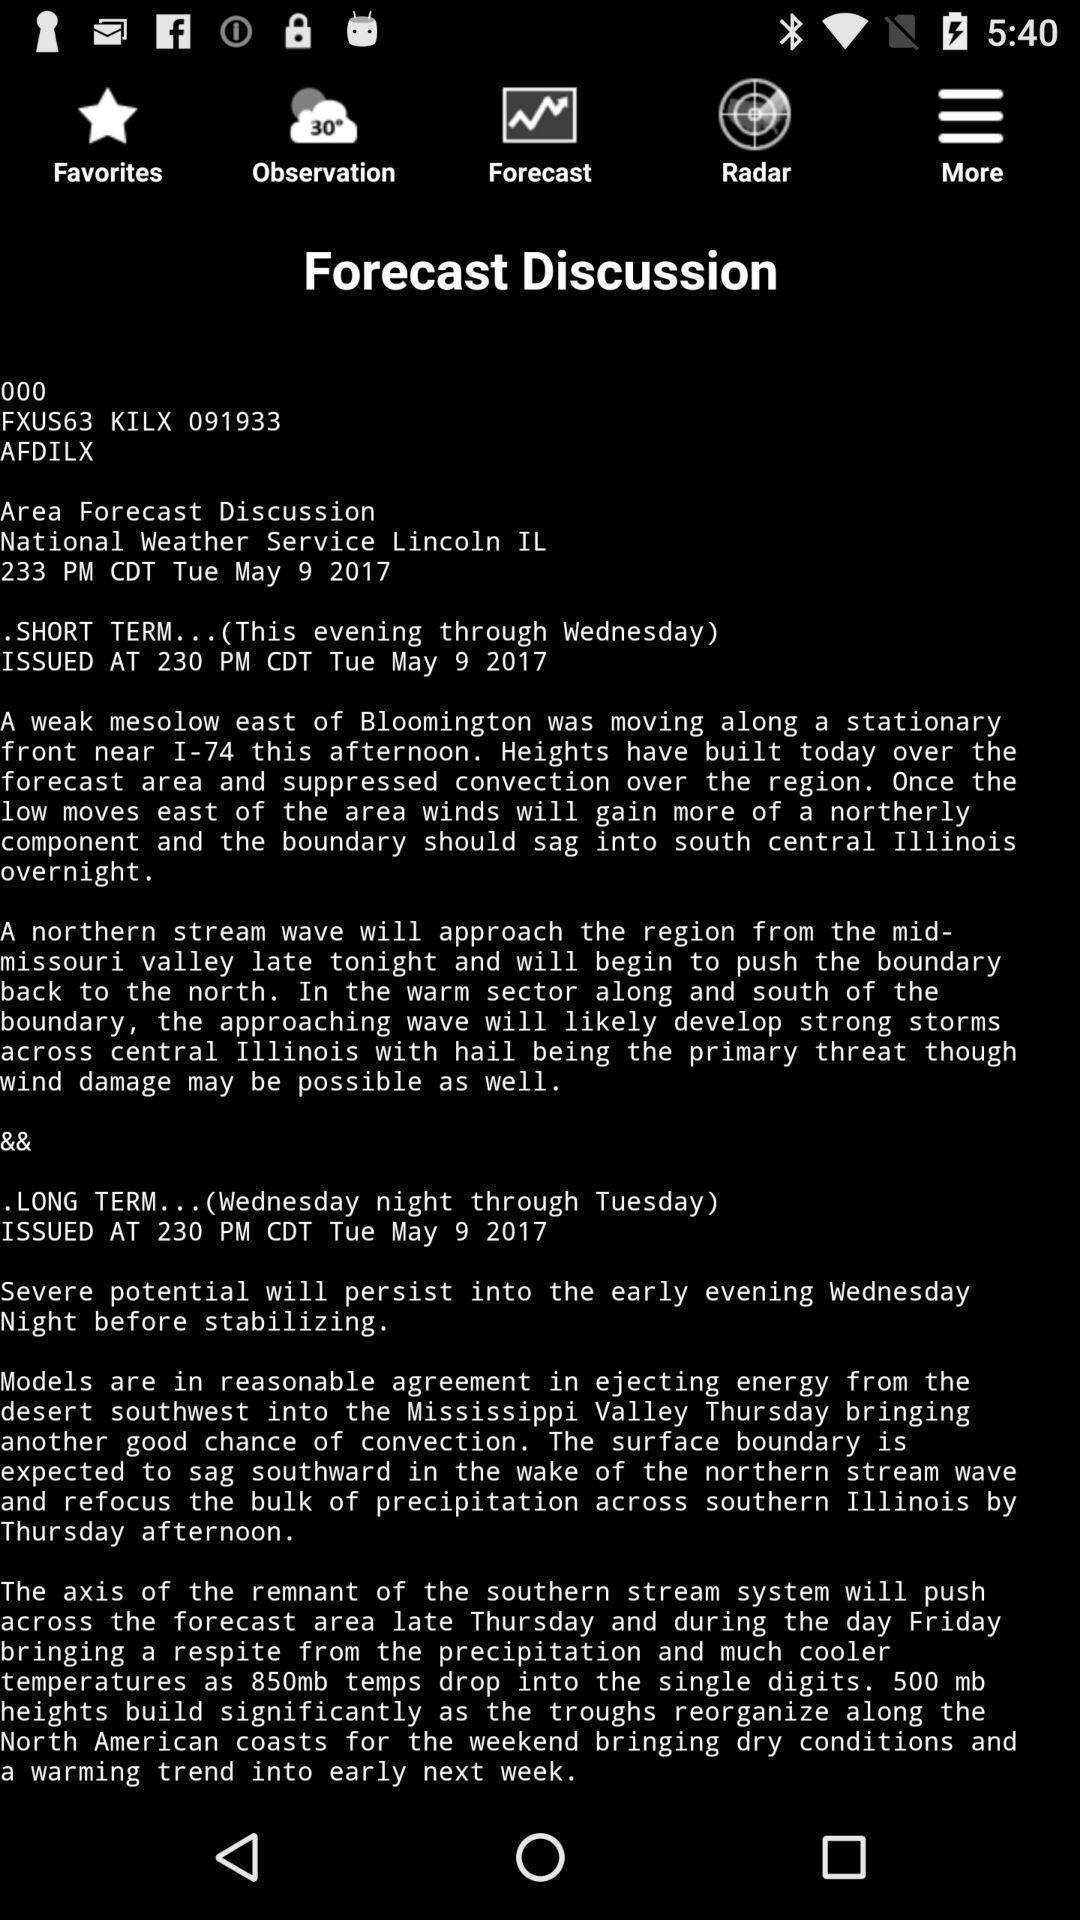Provide a textual representation of this image. Screen shows multiple details in a weather application. 